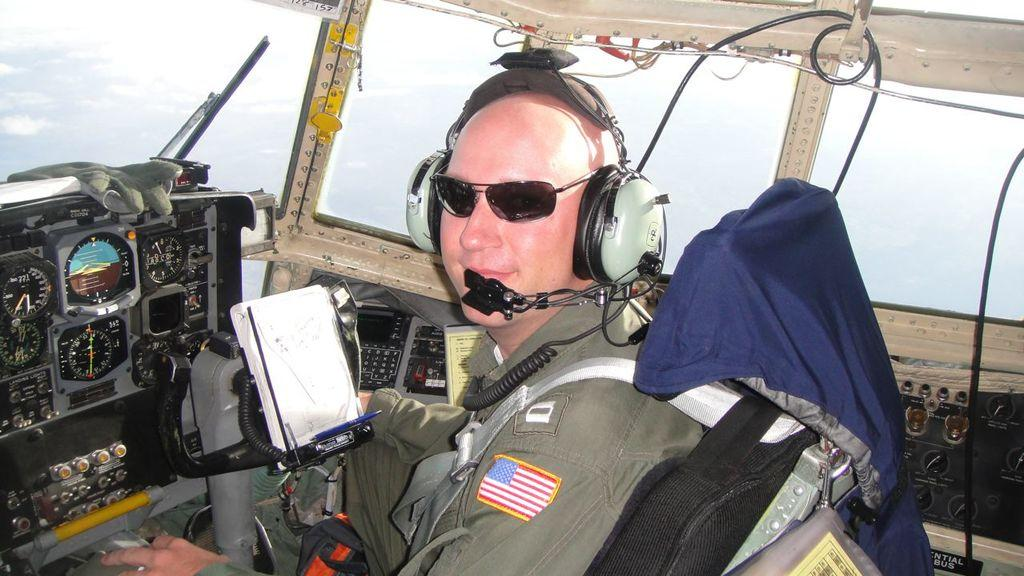What is the main subject in the foreground of the picture? There is a person sitting in the airplane in the foreground of the picture. What can be seen in the background of the picture? There is sky visible in the background of the picture. How many clovers can be seen growing in the airplane? There are no clovers visible in the image, as it features a person sitting in an airplane with sky in the background. 